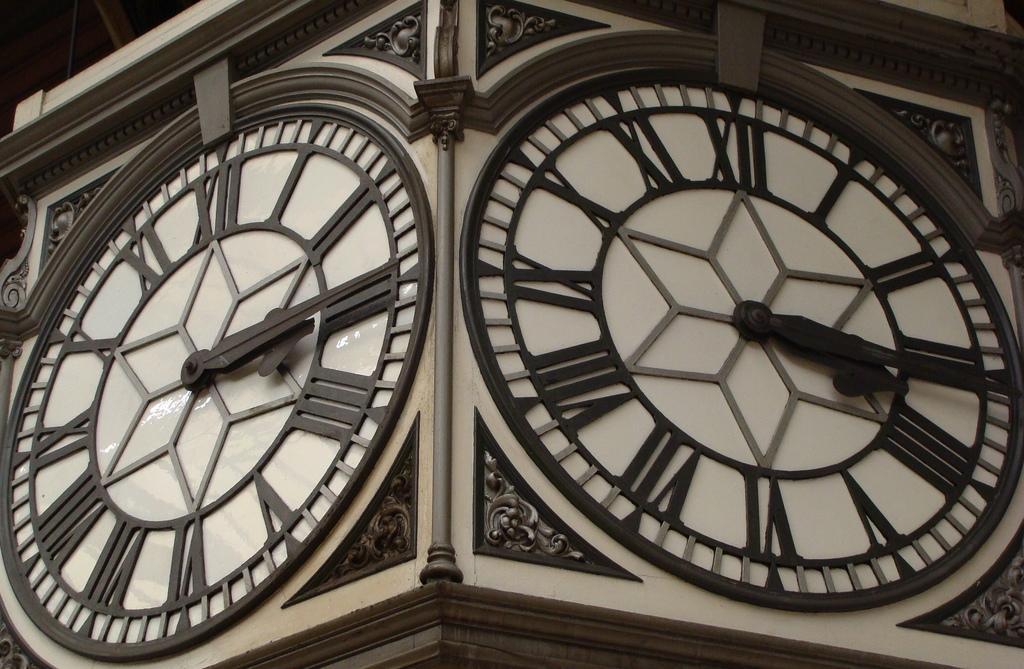Can you describe this image briefly? In this image we can see a clock tower. 